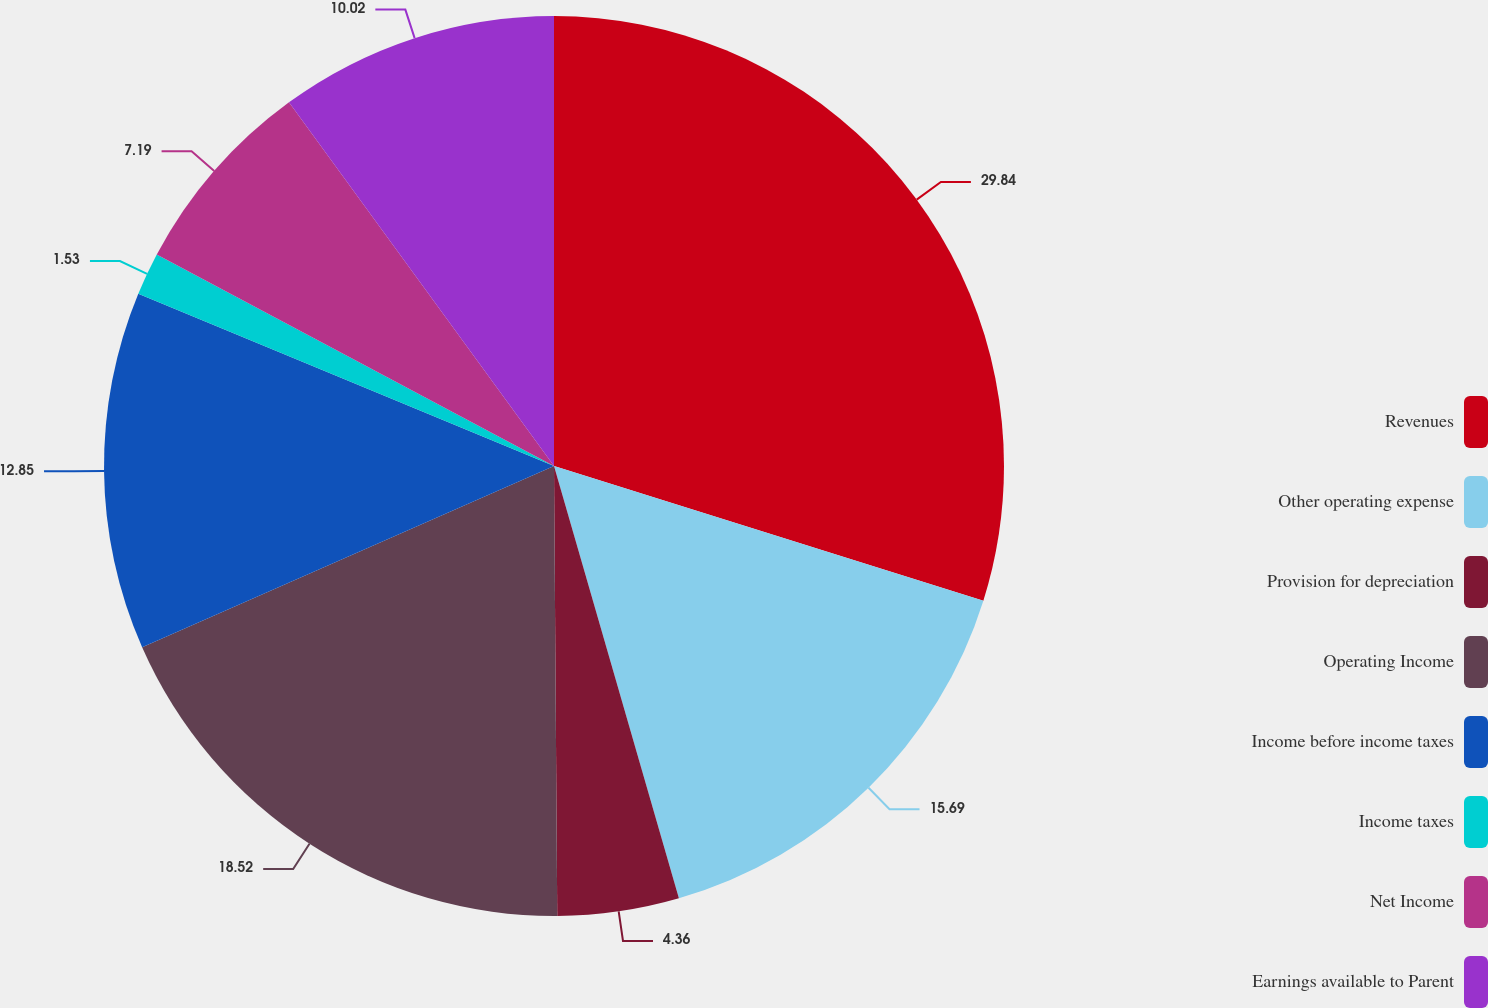<chart> <loc_0><loc_0><loc_500><loc_500><pie_chart><fcel>Revenues<fcel>Other operating expense<fcel>Provision for depreciation<fcel>Operating Income<fcel>Income before income taxes<fcel>Income taxes<fcel>Net Income<fcel>Earnings available to Parent<nl><fcel>29.83%<fcel>15.68%<fcel>4.36%<fcel>18.51%<fcel>12.85%<fcel>1.53%<fcel>7.19%<fcel>10.02%<nl></chart> 